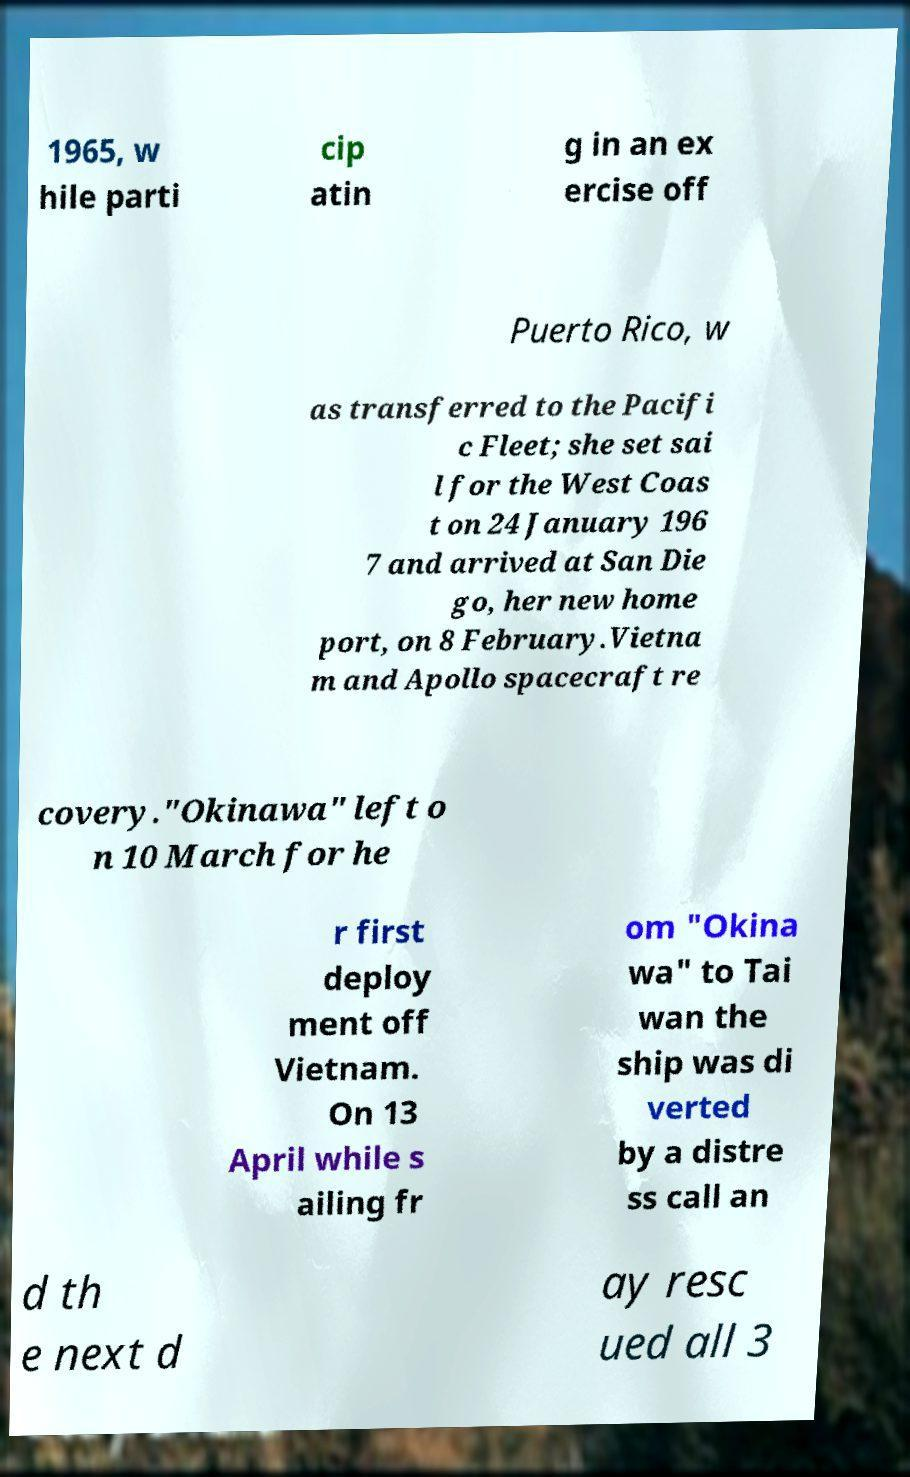Please identify and transcribe the text found in this image. 1965, w hile parti cip atin g in an ex ercise off Puerto Rico, w as transferred to the Pacifi c Fleet; she set sai l for the West Coas t on 24 January 196 7 and arrived at San Die go, her new home port, on 8 February.Vietna m and Apollo spacecraft re covery."Okinawa" left o n 10 March for he r first deploy ment off Vietnam. On 13 April while s ailing fr om "Okina wa" to Tai wan the ship was di verted by a distre ss call an d th e next d ay resc ued all 3 